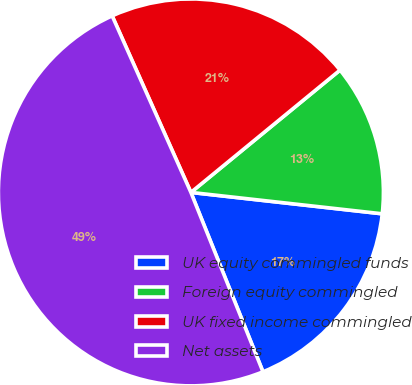Convert chart. <chart><loc_0><loc_0><loc_500><loc_500><pie_chart><fcel>UK equity commingled funds<fcel>Foreign equity commingled<fcel>UK fixed income commingled<fcel>Net assets<nl><fcel>17.13%<fcel>12.66%<fcel>20.81%<fcel>49.4%<nl></chart> 